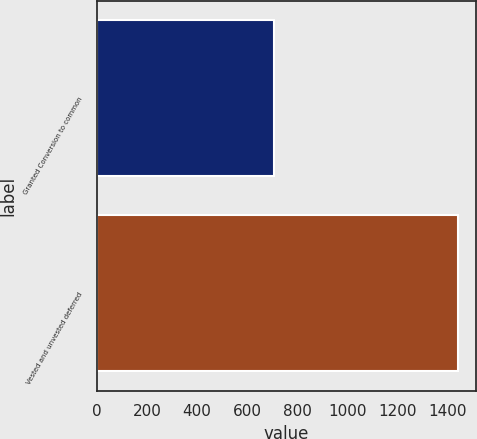Convert chart to OTSL. <chart><loc_0><loc_0><loc_500><loc_500><bar_chart><fcel>Granted Conversion to common<fcel>Vested and unvested deferred<nl><fcel>708<fcel>1440<nl></chart> 